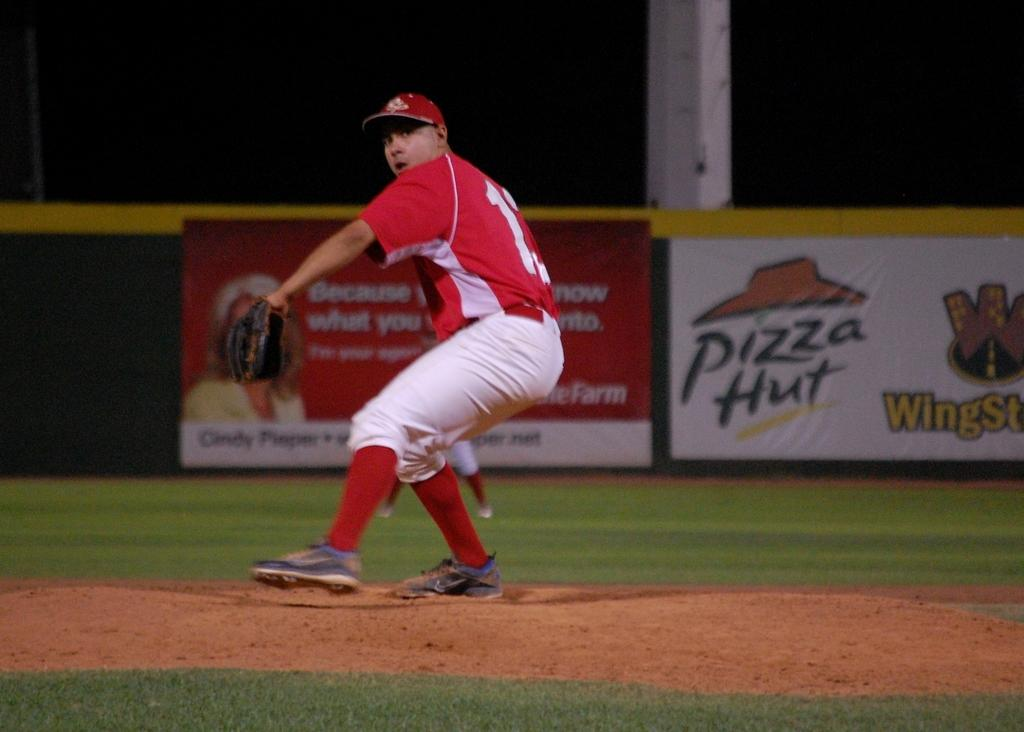<image>
Describe the image concisely. A pitcher throws while standing in front of a Pizza Hut ad. 